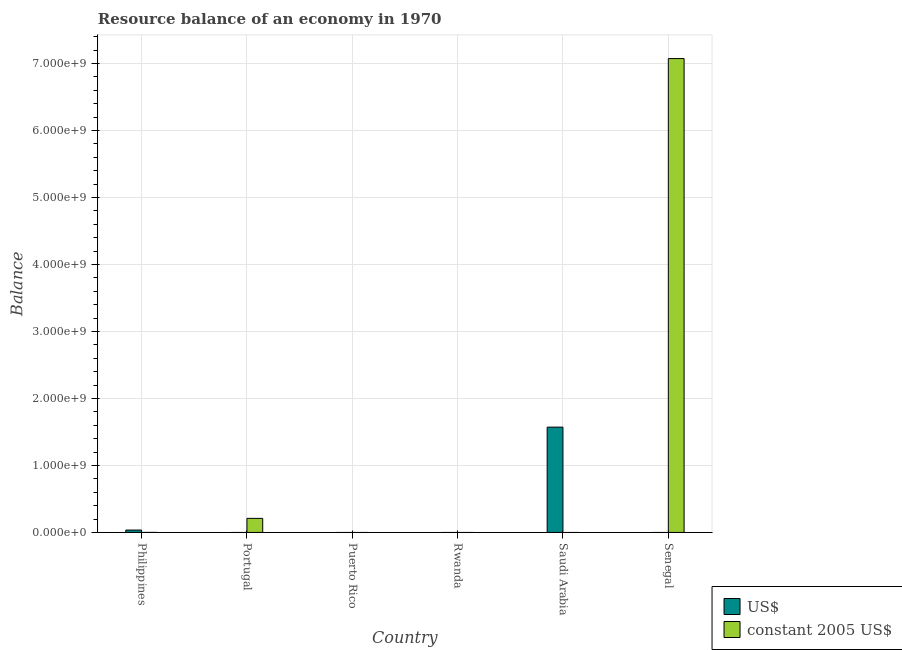How many different coloured bars are there?
Offer a terse response. 2. Are the number of bars on each tick of the X-axis equal?
Your response must be concise. No. How many bars are there on the 4th tick from the left?
Ensure brevity in your answer.  0. How many bars are there on the 2nd tick from the right?
Keep it short and to the point. 1. What is the label of the 1st group of bars from the left?
Make the answer very short. Philippines. In how many cases, is the number of bars for a given country not equal to the number of legend labels?
Offer a very short reply. 5. What is the resource balance in us$ in Saudi Arabia?
Give a very brief answer. 1.57e+09. Across all countries, what is the maximum resource balance in us$?
Keep it short and to the point. 1.57e+09. In which country was the resource balance in constant us$ maximum?
Your answer should be compact. Senegal. What is the total resource balance in constant us$ in the graph?
Your answer should be very brief. 7.29e+09. What is the difference between the resource balance in constant us$ in Philippines and that in Portugal?
Make the answer very short. -2.10e+08. What is the difference between the resource balance in constant us$ in Puerto Rico and the resource balance in us$ in Saudi Arabia?
Your answer should be very brief. -1.57e+09. What is the average resource balance in us$ per country?
Keep it short and to the point. 2.68e+08. What is the ratio of the resource balance in us$ in Philippines to that in Saudi Arabia?
Ensure brevity in your answer.  0.02. What is the difference between the highest and the second highest resource balance in constant us$?
Your answer should be very brief. 6.86e+09. What is the difference between the highest and the lowest resource balance in us$?
Keep it short and to the point. 1.57e+09. In how many countries, is the resource balance in constant us$ greater than the average resource balance in constant us$ taken over all countries?
Offer a very short reply. 1. Is the sum of the resource balance in constant us$ in Portugal and Senegal greater than the maximum resource balance in us$ across all countries?
Make the answer very short. Yes. How many bars are there?
Provide a short and direct response. 5. Are the values on the major ticks of Y-axis written in scientific E-notation?
Your response must be concise. Yes. Does the graph contain grids?
Offer a terse response. Yes. Where does the legend appear in the graph?
Make the answer very short. Bottom right. How are the legend labels stacked?
Provide a short and direct response. Vertical. What is the title of the graph?
Keep it short and to the point. Resource balance of an economy in 1970. What is the label or title of the Y-axis?
Make the answer very short. Balance. What is the Balance of US$ in Philippines?
Your response must be concise. 3.55e+07. What is the Balance in constant 2005 US$ in Philippines?
Your response must be concise. 5.3. What is the Balance of US$ in Portugal?
Make the answer very short. 0. What is the Balance of constant 2005 US$ in Portugal?
Make the answer very short. 2.10e+08. What is the Balance of US$ in Puerto Rico?
Your answer should be compact. 0. What is the Balance of constant 2005 US$ in Puerto Rico?
Your answer should be very brief. 0. What is the Balance of US$ in Saudi Arabia?
Provide a short and direct response. 1.57e+09. What is the Balance of US$ in Senegal?
Provide a succinct answer. 0. What is the Balance in constant 2005 US$ in Senegal?
Make the answer very short. 7.08e+09. Across all countries, what is the maximum Balance in US$?
Your answer should be compact. 1.57e+09. Across all countries, what is the maximum Balance of constant 2005 US$?
Keep it short and to the point. 7.08e+09. Across all countries, what is the minimum Balance of constant 2005 US$?
Offer a very short reply. 0. What is the total Balance in US$ in the graph?
Provide a short and direct response. 1.61e+09. What is the total Balance in constant 2005 US$ in the graph?
Your answer should be compact. 7.29e+09. What is the difference between the Balance in constant 2005 US$ in Philippines and that in Portugal?
Offer a terse response. -2.10e+08. What is the difference between the Balance of US$ in Philippines and that in Saudi Arabia?
Offer a terse response. -1.54e+09. What is the difference between the Balance of constant 2005 US$ in Philippines and that in Senegal?
Make the answer very short. -7.07e+09. What is the difference between the Balance of constant 2005 US$ in Portugal and that in Senegal?
Make the answer very short. -6.86e+09. What is the difference between the Balance in US$ in Philippines and the Balance in constant 2005 US$ in Portugal?
Ensure brevity in your answer.  -1.74e+08. What is the difference between the Balance of US$ in Philippines and the Balance of constant 2005 US$ in Senegal?
Give a very brief answer. -7.04e+09. What is the difference between the Balance in US$ in Saudi Arabia and the Balance in constant 2005 US$ in Senegal?
Give a very brief answer. -5.50e+09. What is the average Balance of US$ per country?
Ensure brevity in your answer.  2.68e+08. What is the average Balance in constant 2005 US$ per country?
Provide a short and direct response. 1.21e+09. What is the difference between the Balance in US$ and Balance in constant 2005 US$ in Philippines?
Offer a very short reply. 3.55e+07. What is the ratio of the Balance in constant 2005 US$ in Philippines to that in Portugal?
Offer a very short reply. 0. What is the ratio of the Balance of US$ in Philippines to that in Saudi Arabia?
Offer a very short reply. 0.02. What is the ratio of the Balance in constant 2005 US$ in Portugal to that in Senegal?
Your response must be concise. 0.03. What is the difference between the highest and the second highest Balance in constant 2005 US$?
Your response must be concise. 6.86e+09. What is the difference between the highest and the lowest Balance in US$?
Give a very brief answer. 1.57e+09. What is the difference between the highest and the lowest Balance in constant 2005 US$?
Keep it short and to the point. 7.08e+09. 